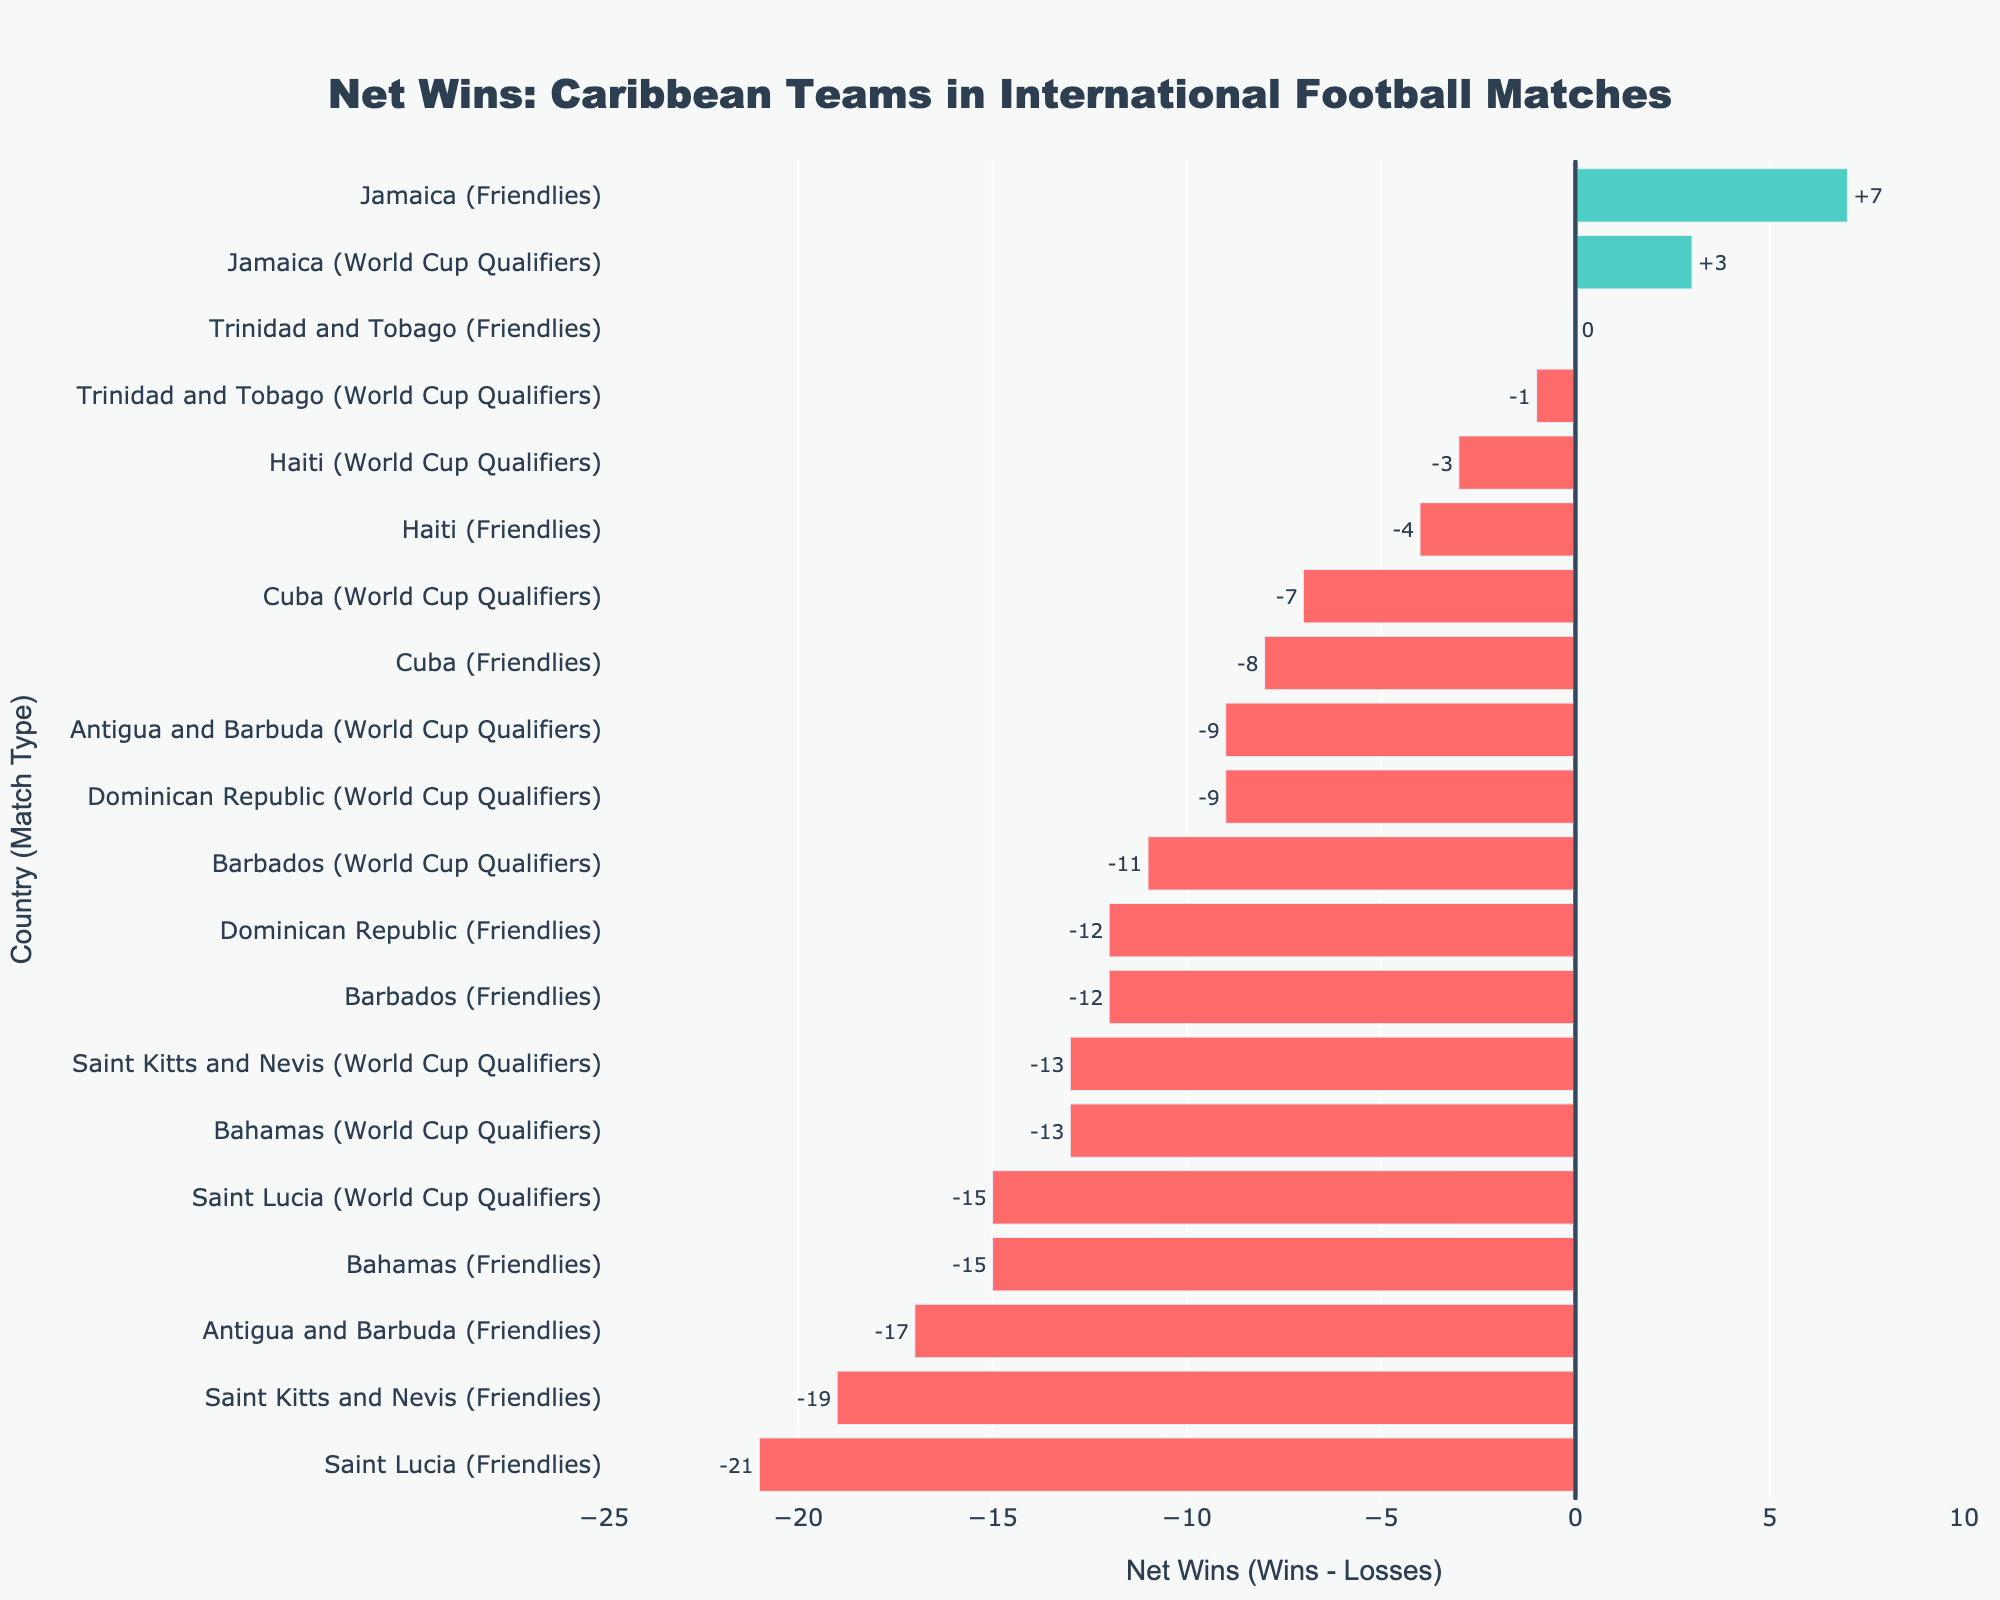Which country has the most net wins in Friendlies? Look for the country with the highest positive net win value specifically for match type 'Friendlies'. Jamaica has the highest net wins in Friendlies.
Answer: Jamaica Which country has the highest negative net wins in World Cup Qualifiers? Check for the country with the lowest net win value specifically for match type 'World Cup Qualifiers'. Saint Lucia has the highest negative net wins in World Cup Qualifiers.
Answer: Saint Lucia What is the total number of wins for Jamaica across all match types? Add the number of wins for Jamaica in both 'Friendlies' and 'World Cup Qualifiers'. Jamaica has 15 wins in Friendlies and 9 wins in World Cup Qualifiers, so the total is 24.
Answer: 24 Which team has achieved a net win of exactly 0 in Friendlies? Identify the team in 'Friendlies' with a net win value of 0. Trinidad and Tobago have equal wins and losses, resulting in a net win of 0 in Friendlies.
Answer: Trinidad and Tobago How many countries have a positive net win in Friendlies? Count the number of countries with a positive net win value specifically for match type 'Friendlies'. Only Jamaica has a positive net win in Friendlies.
Answer: 1 Compare the net wins of Trinidad and Tobago and Haiti in 'World Cup Qualifiers'. Which one is better? Check the net win values for both teams in 'World Cup Qualifiers'. Trinidad and Tobago have a net win of -1, while Haiti has a net win of -3. Therefore, Trinidad and Tobago is better.
Answer: Trinidad and Tobago What is the difference in net wins between the top and bottom performing countries in Friendlies? Identify the top and bottom performing countries in Friendlies in terms of net wins and calculate the difference. Jamaica has the top net wins with +7, and Saint Lucia has the bottom net wins with -21, giving a difference of 28.
Answer: 28 For Antigua and Barbuda, which match type shows better performance in terms of net wins? Compare the net win values for both match types for Antigua and Barbuda. The ‘Friendlies’ net win is -17 and 'World Cup Qualifiers' net win is -9. The 'World Cup Qualifiers' show better performance.
Answer: World Cup Qualifiers 